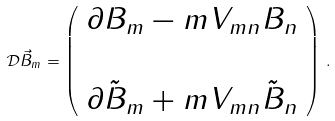Convert formula to latex. <formula><loc_0><loc_0><loc_500><loc_500>\mathcal { D } \vec { B } _ { m } = \left ( \begin{array} { c c } \partial B _ { m } - m V _ { m n } B _ { n } \\ \\ \partial \tilde { B } _ { m } + m V _ { m n } \tilde { B } _ { n } \\ \end{array} \right ) \, .</formula> 